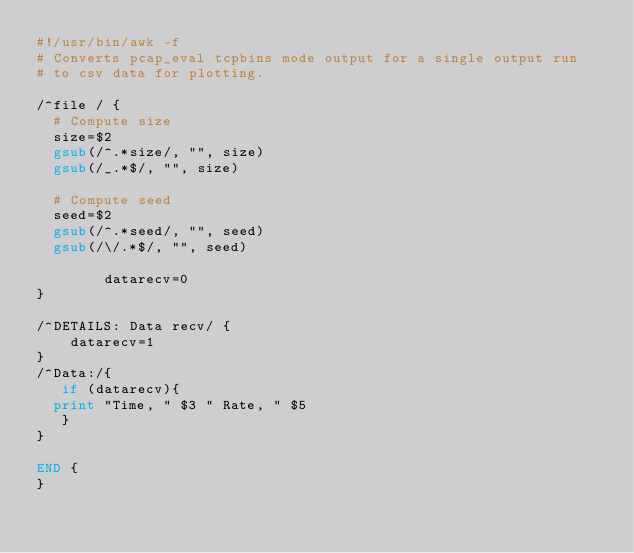<code> <loc_0><loc_0><loc_500><loc_500><_Awk_>#!/usr/bin/awk -f
# Converts pcap_eval tcpbins mode output for a single output run
# to csv data for plotting. 

/^file / {
	# Compute size
	size=$2
	gsub(/^.*size/, "", size)
	gsub(/_.*$/, "", size)

	# Compute seed
	seed=$2
	gsub(/^.*seed/, "", seed)
	gsub(/\/.*$/, "", seed)

        datarecv=0
}

/^DETAILS: Data recv/ {
    datarecv=1
}
/^Data:/{
   if (datarecv){
	print "Time, " $3 " Rate, " $5
   }
}

END {
}
</code> 